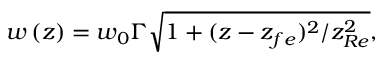<formula> <loc_0><loc_0><loc_500><loc_500>w \left ( z \right ) = w _ { 0 } \Gamma \sqrt { 1 + ( z - z _ { f e } ) ^ { 2 } / z _ { R e } ^ { 2 } } ,</formula> 